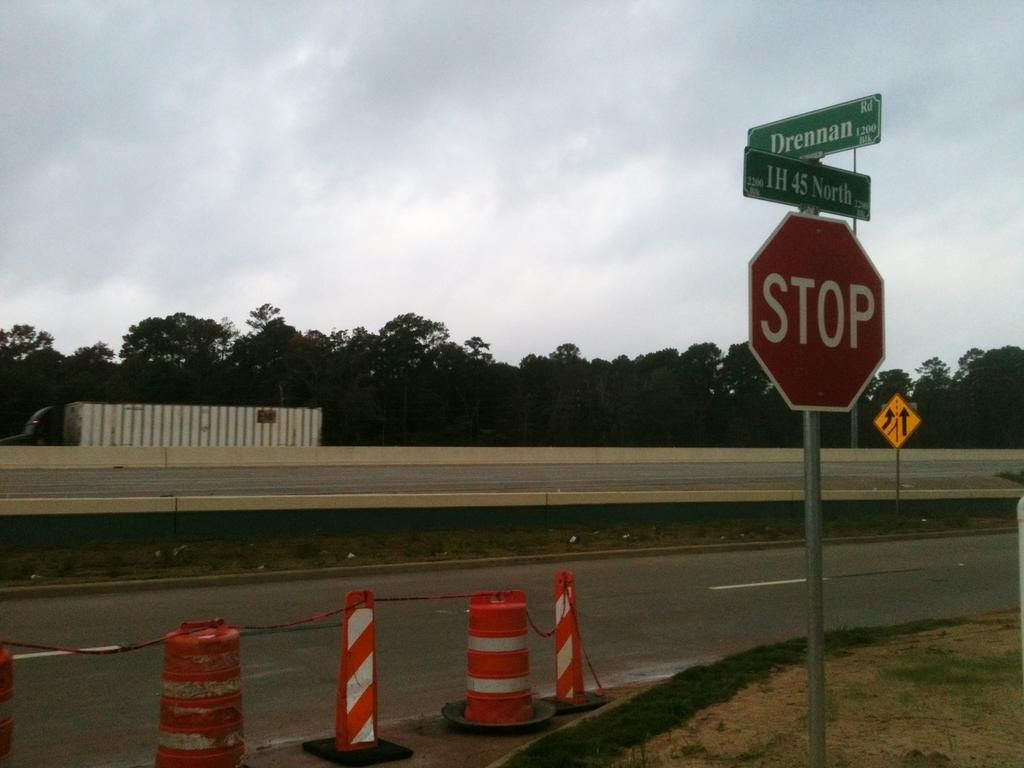Provide a one-sentence caption for the provided image. The road with orange cones and a green street sign with Drennan in white lettering. 